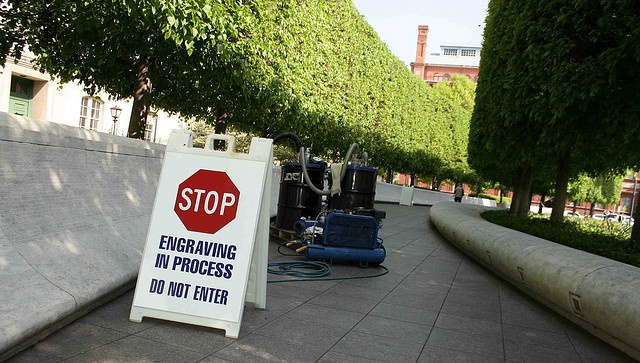Describe the objects in this image and their specific colors. I can see stop sign in black, maroon, white, and brown tones, car in black, white, darkgray, beige, and olive tones, people in black and gray tones, car in black, white, darkgray, olive, and khaki tones, and car in black, white, tan, gray, and darkgray tones in this image. 